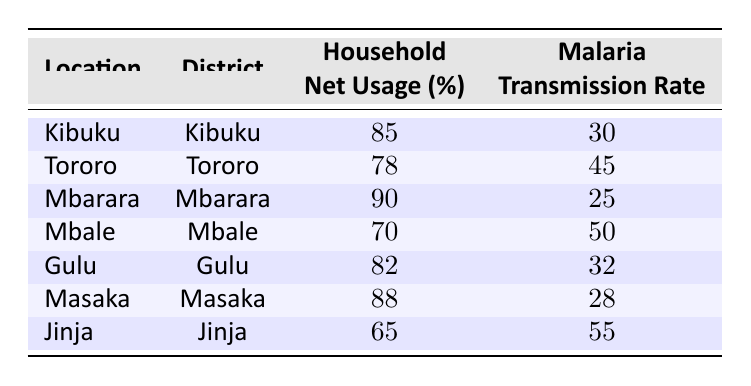What is the malaria transmission rate in Mbarara District? The table shows that the malaria transmission rate for Mbarara District is listed in the relevant row. Referring to that row, the transmission rate is 25.
Answer: 25 What is the household insecticide net usage percentage in Tororo District? Referring to the Tororo District row in the table, we can see that the household insecticide net usage percentage is 78.
Answer: 78 Is it true that Jinja District has the highest malaria transmission rate? By checking the transmission rates listed, Jinja District has a transmission rate of 55. The other districts have lower rates: Kibuku (30), Tororo (45), Mbarara (25), Mbale (50), Gulu (32), and Masaka (28). Thus, Jinja does have the highest rate.
Answer: Yes What is the difference in household insecticide net usage between Mbarara and Mbale Districts? Mbarara has a net usage of 90% and Mbale has 70%. The difference is calculated as 90 - 70 = 20.
Answer: 20 What is the average household insecticide net usage percentage across all districts in the table? To find the average, add up the net usage percentages: 85 + 78 + 90 + 70 + 82 + 88 + 65 = 558. There are 7 districts, so the average is 558 / 7 = 79.71.
Answer: 79.71 Which district has the lowest household insecticide net usage percentage, and what is that percentage? Comparing the percentages across all districts, Jinja has the lowest usage at 65%.
Answer: Jinja, 65 What is the relationship between household insecticide net usage and malaria transmission rate in terms of correlation? Observing the percentages and transmission rates, it appears that higher usage percentages correlate with lower transmission rates (e.g., Mbarara at 90% with 25 rate, versus Jinja at 65% with 55 rate). This suggests a negative correlation. However, further statistical analysis would be needed to quantify the correlation.
Answer: Negative correlation Which district has a household insecticide net usage percentage greater than 80 but has a malaria transmission rate greater than 30? From the table, the districts with usage over 80% are Kibuku (85%), Mbarara (90%), Gulu (82%), and Masaka (88%). Among these, only Gulu has a transmission rate over 30 (32), while Kibuku (30) and Mbarara (25) do not. Therefore, Gulu is the only district that meets the criteria.
Answer: Gulu What is the sum of malaria transmission rates for all districts listed in the table? Adding the transmission rates together: 30 + 45 + 25 + 50 + 32 + 28 + 55 = 265.
Answer: 265 